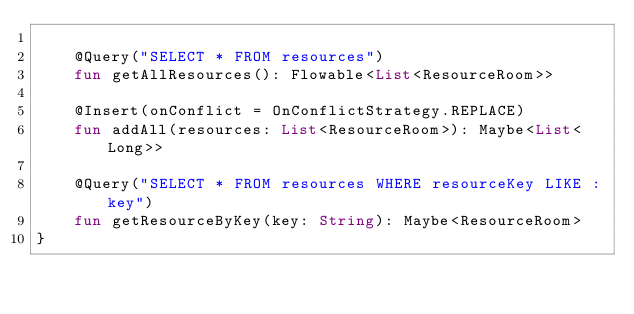Convert code to text. <code><loc_0><loc_0><loc_500><loc_500><_Kotlin_>
    @Query("SELECT * FROM resources")
    fun getAllResources(): Flowable<List<ResourceRoom>>

    @Insert(onConflict = OnConflictStrategy.REPLACE)
    fun addAll(resources: List<ResourceRoom>): Maybe<List<Long>>

    @Query("SELECT * FROM resources WHERE resourceKey LIKE :key")
    fun getResourceByKey(key: String): Maybe<ResourceRoom>
}</code> 